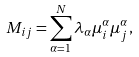Convert formula to latex. <formula><loc_0><loc_0><loc_500><loc_500>M _ { i j } = \sum _ { \alpha = 1 } ^ { N } \lambda _ { \alpha } \mu _ { i } ^ { \alpha } \mu _ { j } ^ { \alpha } ,</formula> 